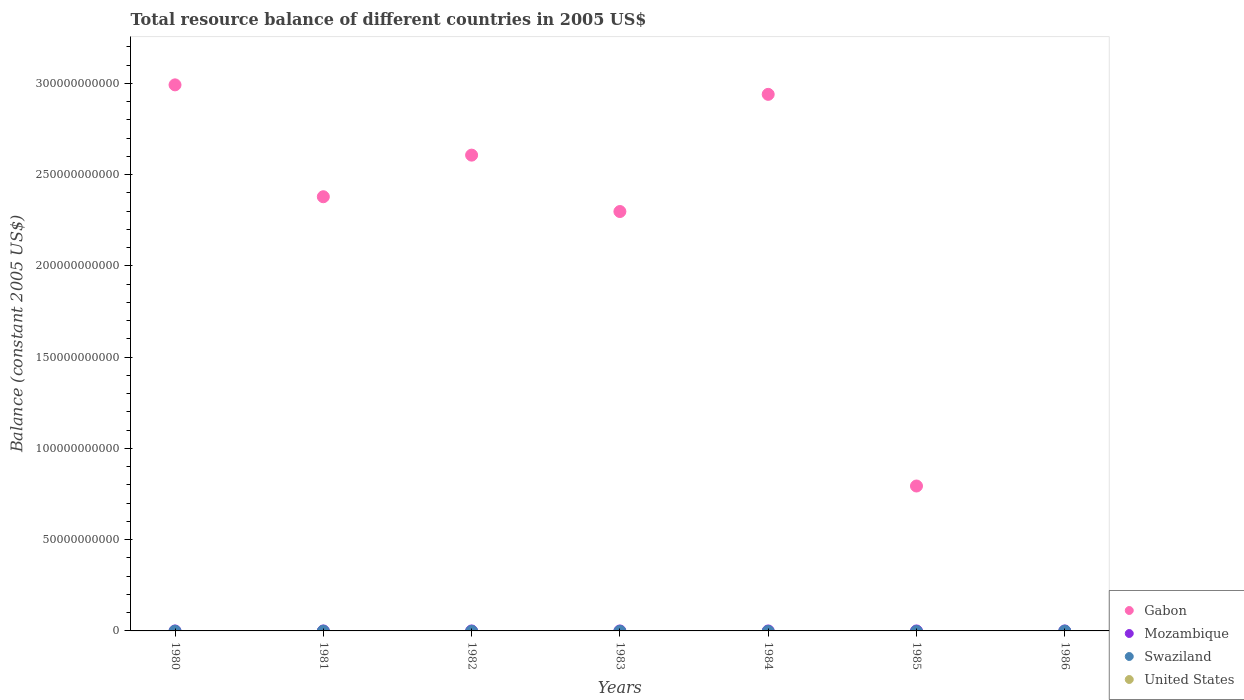Is the number of dotlines equal to the number of legend labels?
Offer a terse response. No. What is the total resource balance in Swaziland in 1981?
Make the answer very short. 0. Across all years, what is the maximum total resource balance in Gabon?
Your answer should be compact. 2.99e+11. What is the total total resource balance in Gabon in the graph?
Keep it short and to the point. 1.40e+12. What is the difference between the total resource balance in Gabon in 1981 and the total resource balance in United States in 1986?
Give a very brief answer. 2.38e+11. What is the average total resource balance in Gabon per year?
Give a very brief answer. 2.00e+11. What is the ratio of the total resource balance in Gabon in 1981 to that in 1985?
Your response must be concise. 3. What is the difference between the highest and the second highest total resource balance in Gabon?
Make the answer very short. 5.20e+09. What is the difference between the highest and the lowest total resource balance in Gabon?
Keep it short and to the point. 2.99e+11. In how many years, is the total resource balance in Gabon greater than the average total resource balance in Gabon taken over all years?
Offer a very short reply. 5. Is the sum of the total resource balance in Gabon in 1982 and 1985 greater than the maximum total resource balance in Mozambique across all years?
Your answer should be compact. Yes. Is it the case that in every year, the sum of the total resource balance in Mozambique and total resource balance in United States  is greater than the sum of total resource balance in Swaziland and total resource balance in Gabon?
Your answer should be compact. No. Does the total resource balance in United States monotonically increase over the years?
Offer a terse response. No. Is the total resource balance in Swaziland strictly greater than the total resource balance in United States over the years?
Give a very brief answer. Yes. Is the total resource balance in United States strictly less than the total resource balance in Gabon over the years?
Keep it short and to the point. No. How many years are there in the graph?
Ensure brevity in your answer.  7. Does the graph contain any zero values?
Your answer should be compact. Yes. Does the graph contain grids?
Your answer should be compact. No. Where does the legend appear in the graph?
Offer a terse response. Bottom right. How are the legend labels stacked?
Give a very brief answer. Vertical. What is the title of the graph?
Give a very brief answer. Total resource balance of different countries in 2005 US$. Does "Czech Republic" appear as one of the legend labels in the graph?
Keep it short and to the point. No. What is the label or title of the X-axis?
Your answer should be compact. Years. What is the label or title of the Y-axis?
Ensure brevity in your answer.  Balance (constant 2005 US$). What is the Balance (constant 2005 US$) of Gabon in 1980?
Provide a succinct answer. 2.99e+11. What is the Balance (constant 2005 US$) in United States in 1980?
Make the answer very short. 0. What is the Balance (constant 2005 US$) of Gabon in 1981?
Make the answer very short. 2.38e+11. What is the Balance (constant 2005 US$) of United States in 1981?
Provide a succinct answer. 0. What is the Balance (constant 2005 US$) in Gabon in 1982?
Your response must be concise. 2.61e+11. What is the Balance (constant 2005 US$) in Mozambique in 1982?
Provide a short and direct response. 0. What is the Balance (constant 2005 US$) in Swaziland in 1982?
Provide a succinct answer. 0. What is the Balance (constant 2005 US$) in United States in 1982?
Ensure brevity in your answer.  0. What is the Balance (constant 2005 US$) in Gabon in 1983?
Ensure brevity in your answer.  2.30e+11. What is the Balance (constant 2005 US$) of Mozambique in 1983?
Provide a succinct answer. 0. What is the Balance (constant 2005 US$) of United States in 1983?
Provide a succinct answer. 0. What is the Balance (constant 2005 US$) in Gabon in 1984?
Ensure brevity in your answer.  2.94e+11. What is the Balance (constant 2005 US$) in Swaziland in 1984?
Provide a succinct answer. 0. What is the Balance (constant 2005 US$) of Gabon in 1985?
Keep it short and to the point. 7.94e+1. What is the Balance (constant 2005 US$) of Mozambique in 1985?
Offer a very short reply. 0. What is the Balance (constant 2005 US$) in Swaziland in 1985?
Offer a very short reply. 0. What is the Balance (constant 2005 US$) of Gabon in 1986?
Give a very brief answer. 0. What is the Balance (constant 2005 US$) of Mozambique in 1986?
Offer a terse response. 0. What is the Balance (constant 2005 US$) of Swaziland in 1986?
Ensure brevity in your answer.  0. Across all years, what is the maximum Balance (constant 2005 US$) in Gabon?
Make the answer very short. 2.99e+11. What is the total Balance (constant 2005 US$) of Gabon in the graph?
Provide a short and direct response. 1.40e+12. What is the total Balance (constant 2005 US$) of Mozambique in the graph?
Make the answer very short. 0. What is the total Balance (constant 2005 US$) in Swaziland in the graph?
Keep it short and to the point. 0. What is the difference between the Balance (constant 2005 US$) of Gabon in 1980 and that in 1981?
Offer a terse response. 6.13e+1. What is the difference between the Balance (constant 2005 US$) in Gabon in 1980 and that in 1982?
Offer a terse response. 3.85e+1. What is the difference between the Balance (constant 2005 US$) in Gabon in 1980 and that in 1983?
Make the answer very short. 6.94e+1. What is the difference between the Balance (constant 2005 US$) in Gabon in 1980 and that in 1984?
Your response must be concise. 5.20e+09. What is the difference between the Balance (constant 2005 US$) in Gabon in 1980 and that in 1985?
Make the answer very short. 2.20e+11. What is the difference between the Balance (constant 2005 US$) in Gabon in 1981 and that in 1982?
Provide a short and direct response. -2.28e+1. What is the difference between the Balance (constant 2005 US$) of Gabon in 1981 and that in 1983?
Provide a succinct answer. 8.10e+09. What is the difference between the Balance (constant 2005 US$) of Gabon in 1981 and that in 1984?
Provide a short and direct response. -5.61e+1. What is the difference between the Balance (constant 2005 US$) of Gabon in 1981 and that in 1985?
Your answer should be very brief. 1.58e+11. What is the difference between the Balance (constant 2005 US$) of Gabon in 1982 and that in 1983?
Your answer should be very brief. 3.09e+1. What is the difference between the Balance (constant 2005 US$) in Gabon in 1982 and that in 1984?
Provide a short and direct response. -3.33e+1. What is the difference between the Balance (constant 2005 US$) of Gabon in 1982 and that in 1985?
Keep it short and to the point. 1.81e+11. What is the difference between the Balance (constant 2005 US$) in Gabon in 1983 and that in 1984?
Provide a short and direct response. -6.42e+1. What is the difference between the Balance (constant 2005 US$) of Gabon in 1983 and that in 1985?
Give a very brief answer. 1.50e+11. What is the difference between the Balance (constant 2005 US$) of Gabon in 1984 and that in 1985?
Give a very brief answer. 2.15e+11. What is the average Balance (constant 2005 US$) of Gabon per year?
Your response must be concise. 2.00e+11. What is the average Balance (constant 2005 US$) in United States per year?
Provide a succinct answer. 0. What is the ratio of the Balance (constant 2005 US$) in Gabon in 1980 to that in 1981?
Provide a short and direct response. 1.26. What is the ratio of the Balance (constant 2005 US$) in Gabon in 1980 to that in 1982?
Ensure brevity in your answer.  1.15. What is the ratio of the Balance (constant 2005 US$) of Gabon in 1980 to that in 1983?
Your answer should be very brief. 1.3. What is the ratio of the Balance (constant 2005 US$) in Gabon in 1980 to that in 1984?
Your response must be concise. 1.02. What is the ratio of the Balance (constant 2005 US$) in Gabon in 1980 to that in 1985?
Make the answer very short. 3.77. What is the ratio of the Balance (constant 2005 US$) in Gabon in 1981 to that in 1982?
Offer a very short reply. 0.91. What is the ratio of the Balance (constant 2005 US$) in Gabon in 1981 to that in 1983?
Offer a terse response. 1.04. What is the ratio of the Balance (constant 2005 US$) of Gabon in 1981 to that in 1984?
Give a very brief answer. 0.81. What is the ratio of the Balance (constant 2005 US$) in Gabon in 1981 to that in 1985?
Your answer should be compact. 3. What is the ratio of the Balance (constant 2005 US$) of Gabon in 1982 to that in 1983?
Give a very brief answer. 1.13. What is the ratio of the Balance (constant 2005 US$) of Gabon in 1982 to that in 1984?
Make the answer very short. 0.89. What is the ratio of the Balance (constant 2005 US$) in Gabon in 1982 to that in 1985?
Give a very brief answer. 3.28. What is the ratio of the Balance (constant 2005 US$) in Gabon in 1983 to that in 1984?
Your answer should be very brief. 0.78. What is the ratio of the Balance (constant 2005 US$) in Gabon in 1983 to that in 1985?
Offer a terse response. 2.89. What is the ratio of the Balance (constant 2005 US$) in Gabon in 1984 to that in 1985?
Offer a terse response. 3.7. What is the difference between the highest and the second highest Balance (constant 2005 US$) in Gabon?
Your answer should be very brief. 5.20e+09. What is the difference between the highest and the lowest Balance (constant 2005 US$) of Gabon?
Your response must be concise. 2.99e+11. 